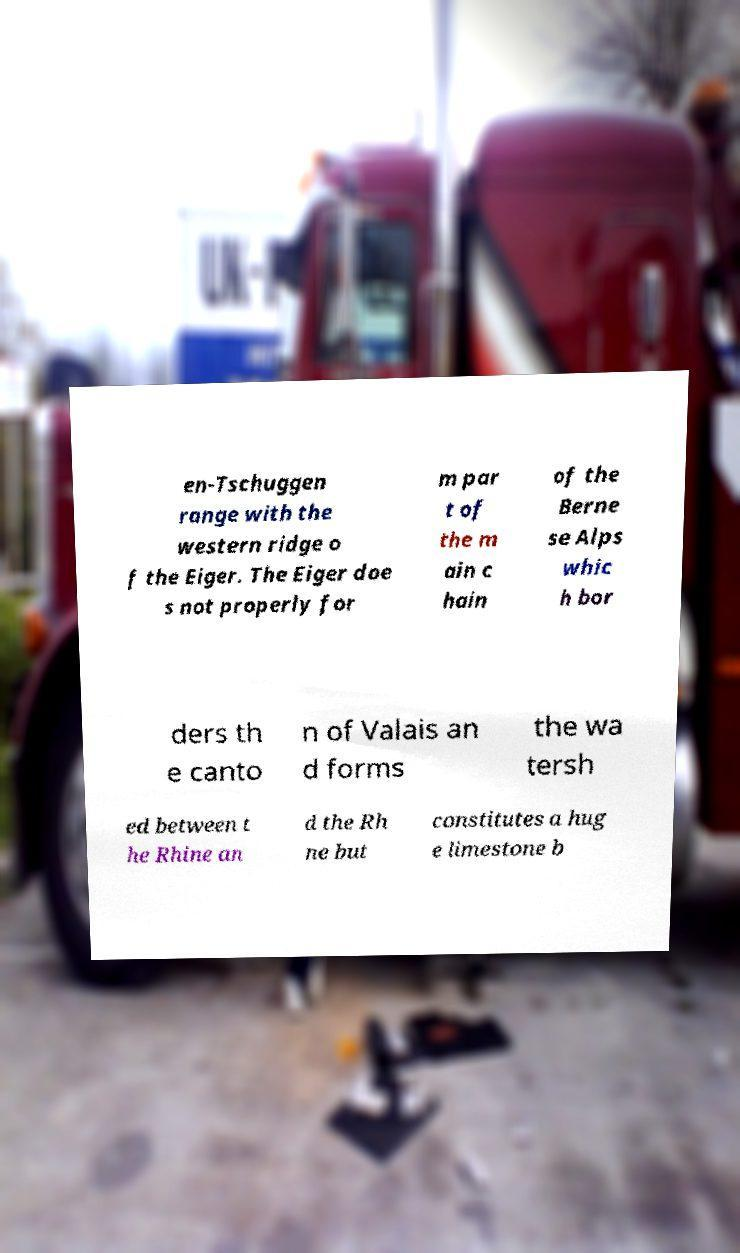Could you assist in decoding the text presented in this image and type it out clearly? en-Tschuggen range with the western ridge o f the Eiger. The Eiger doe s not properly for m par t of the m ain c hain of the Berne se Alps whic h bor ders th e canto n of Valais an d forms the wa tersh ed between t he Rhine an d the Rh ne but constitutes a hug e limestone b 